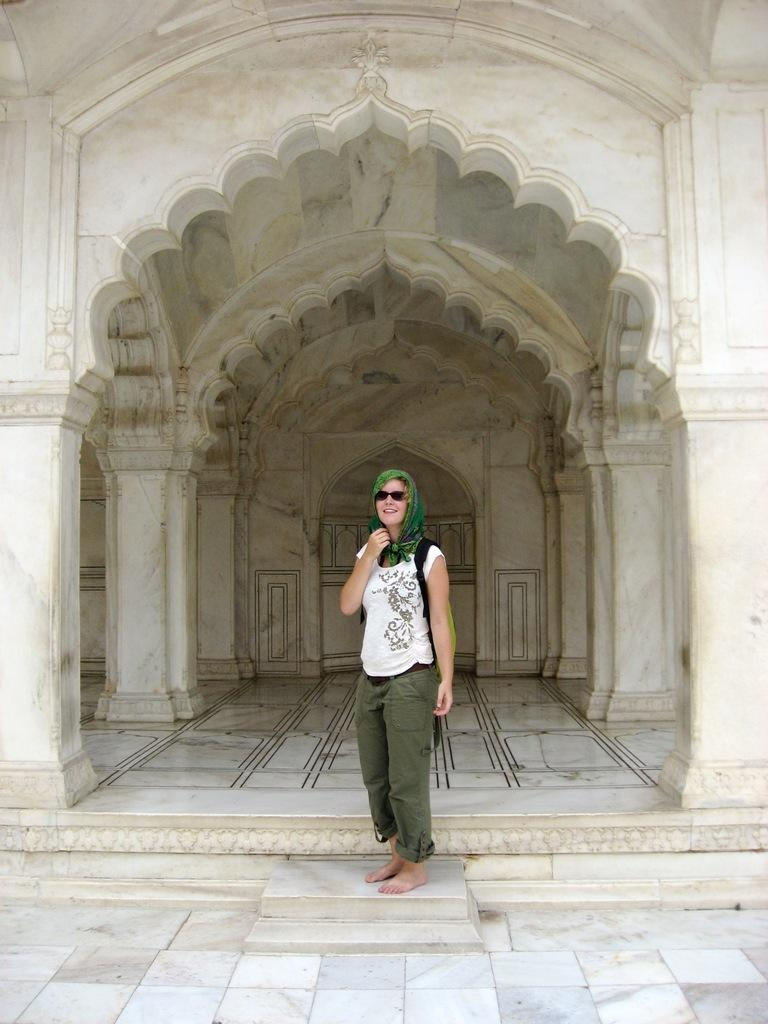What is the person in the image wearing on their upper body? The person is wearing a white T-shirt. What accessories can be seen on the person in the image? The person is wearing a scarf, glasses, and a backpack. What is the person's facial expression in the image? The person is smiling in the image. What can be seen in the background of the image? There is marble architecture in the background of the image. Where is the toothbrush located in the image? There is no toothbrush present in the image. What type of beam is supporting the marble architecture in the image? The image does not provide information about the specific type of beam supporting the marble architecture. 